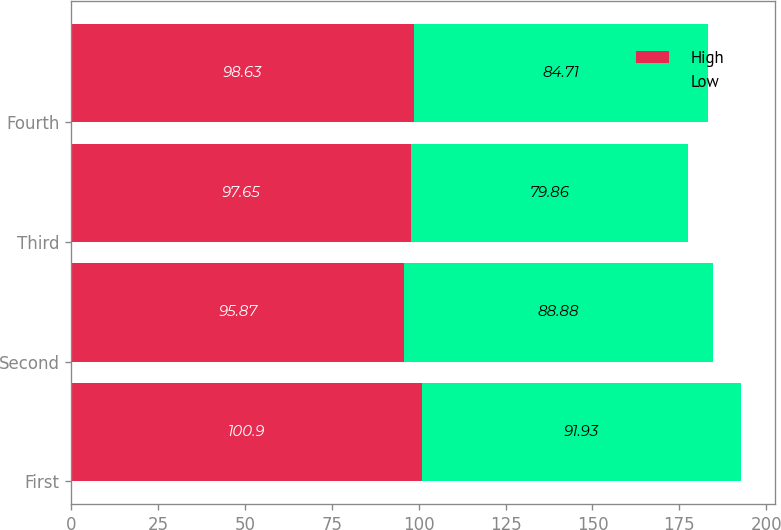<chart> <loc_0><loc_0><loc_500><loc_500><stacked_bar_chart><ecel><fcel>First<fcel>Second<fcel>Third<fcel>Fourth<nl><fcel>High<fcel>100.9<fcel>95.87<fcel>97.65<fcel>98.63<nl><fcel>Low<fcel>91.93<fcel>88.88<fcel>79.86<fcel>84.71<nl></chart> 